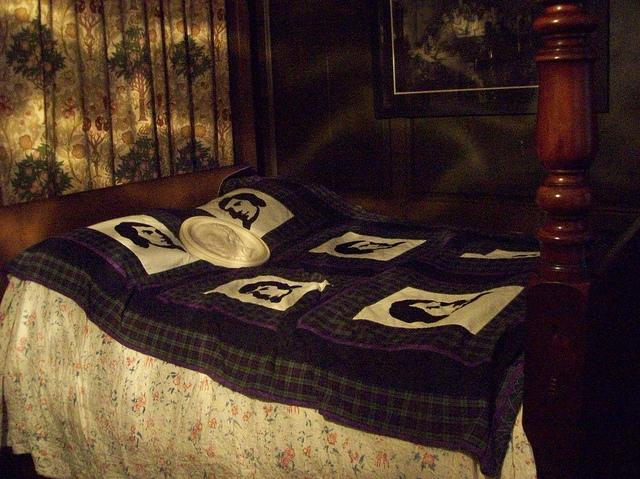What is on the bed? Please explain your reasoning. faces. The faces are on the bed. 